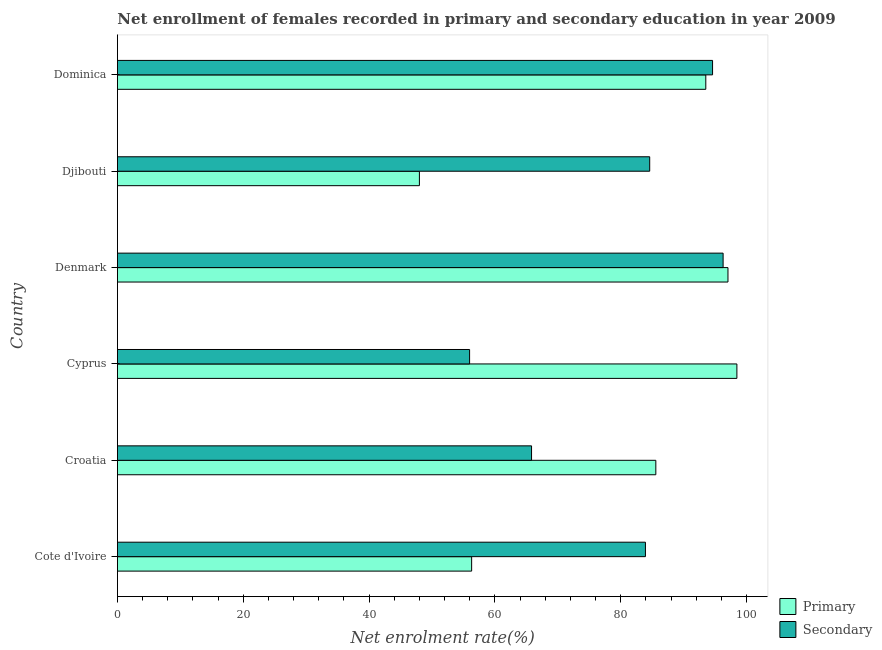How many groups of bars are there?
Your answer should be very brief. 6. Are the number of bars per tick equal to the number of legend labels?
Offer a very short reply. Yes. How many bars are there on the 2nd tick from the top?
Give a very brief answer. 2. How many bars are there on the 2nd tick from the bottom?
Make the answer very short. 2. What is the label of the 6th group of bars from the top?
Offer a terse response. Cote d'Ivoire. In how many cases, is the number of bars for a given country not equal to the number of legend labels?
Your answer should be compact. 0. What is the enrollment rate in primary education in Croatia?
Give a very brief answer. 85.56. Across all countries, what is the maximum enrollment rate in secondary education?
Offer a terse response. 96.26. Across all countries, what is the minimum enrollment rate in primary education?
Give a very brief answer. 47.99. In which country was the enrollment rate in secondary education minimum?
Provide a succinct answer. Cyprus. What is the total enrollment rate in primary education in the graph?
Offer a very short reply. 478.83. What is the difference between the enrollment rate in primary education in Cyprus and that in Dominica?
Your response must be concise. 4.94. What is the difference between the enrollment rate in primary education in Croatia and the enrollment rate in secondary education in Cyprus?
Make the answer very short. 29.59. What is the average enrollment rate in primary education per country?
Your answer should be very brief. 79.8. What is the difference between the enrollment rate in primary education and enrollment rate in secondary education in Croatia?
Provide a short and direct response. 19.75. What is the ratio of the enrollment rate in primary education in Cote d'Ivoire to that in Dominica?
Offer a very short reply. 0.6. Is the enrollment rate in secondary education in Cote d'Ivoire less than that in Denmark?
Ensure brevity in your answer.  Yes. What is the difference between the highest and the second highest enrollment rate in primary education?
Provide a short and direct response. 1.42. What is the difference between the highest and the lowest enrollment rate in secondary education?
Give a very brief answer. 40.29. What does the 2nd bar from the top in Cote d'Ivoire represents?
Give a very brief answer. Primary. What does the 1st bar from the bottom in Djibouti represents?
Ensure brevity in your answer.  Primary. How many countries are there in the graph?
Your response must be concise. 6. Does the graph contain any zero values?
Ensure brevity in your answer.  No. Does the graph contain grids?
Your response must be concise. No. How are the legend labels stacked?
Make the answer very short. Vertical. What is the title of the graph?
Your response must be concise. Net enrollment of females recorded in primary and secondary education in year 2009. Does "Total Population" appear as one of the legend labels in the graph?
Keep it short and to the point. No. What is the label or title of the X-axis?
Give a very brief answer. Net enrolment rate(%). What is the Net enrolment rate(%) in Primary in Cote d'Ivoire?
Provide a succinct answer. 56.29. What is the Net enrolment rate(%) of Secondary in Cote d'Ivoire?
Give a very brief answer. 83.91. What is the Net enrolment rate(%) in Primary in Croatia?
Keep it short and to the point. 85.56. What is the Net enrolment rate(%) of Secondary in Croatia?
Your response must be concise. 65.81. What is the Net enrolment rate(%) in Primary in Cyprus?
Make the answer very short. 98.45. What is the Net enrolment rate(%) of Secondary in Cyprus?
Provide a succinct answer. 55.97. What is the Net enrolment rate(%) of Primary in Denmark?
Give a very brief answer. 97.03. What is the Net enrolment rate(%) of Secondary in Denmark?
Make the answer very short. 96.26. What is the Net enrolment rate(%) of Primary in Djibouti?
Provide a succinct answer. 47.99. What is the Net enrolment rate(%) of Secondary in Djibouti?
Ensure brevity in your answer.  84.59. What is the Net enrolment rate(%) of Primary in Dominica?
Ensure brevity in your answer.  93.5. What is the Net enrolment rate(%) of Secondary in Dominica?
Give a very brief answer. 94.58. Across all countries, what is the maximum Net enrolment rate(%) of Primary?
Keep it short and to the point. 98.45. Across all countries, what is the maximum Net enrolment rate(%) in Secondary?
Your answer should be compact. 96.26. Across all countries, what is the minimum Net enrolment rate(%) in Primary?
Provide a short and direct response. 47.99. Across all countries, what is the minimum Net enrolment rate(%) of Secondary?
Ensure brevity in your answer.  55.97. What is the total Net enrolment rate(%) in Primary in the graph?
Give a very brief answer. 478.83. What is the total Net enrolment rate(%) of Secondary in the graph?
Your response must be concise. 481.12. What is the difference between the Net enrolment rate(%) of Primary in Cote d'Ivoire and that in Croatia?
Ensure brevity in your answer.  -29.27. What is the difference between the Net enrolment rate(%) of Secondary in Cote d'Ivoire and that in Croatia?
Keep it short and to the point. 18.1. What is the difference between the Net enrolment rate(%) in Primary in Cote d'Ivoire and that in Cyprus?
Your answer should be compact. -42.15. What is the difference between the Net enrolment rate(%) in Secondary in Cote d'Ivoire and that in Cyprus?
Your answer should be compact. 27.94. What is the difference between the Net enrolment rate(%) in Primary in Cote d'Ivoire and that in Denmark?
Your response must be concise. -40.73. What is the difference between the Net enrolment rate(%) in Secondary in Cote d'Ivoire and that in Denmark?
Keep it short and to the point. -12.34. What is the difference between the Net enrolment rate(%) in Primary in Cote d'Ivoire and that in Djibouti?
Your answer should be compact. 8.3. What is the difference between the Net enrolment rate(%) of Secondary in Cote d'Ivoire and that in Djibouti?
Provide a succinct answer. -0.68. What is the difference between the Net enrolment rate(%) of Primary in Cote d'Ivoire and that in Dominica?
Provide a succinct answer. -37.21. What is the difference between the Net enrolment rate(%) in Secondary in Cote d'Ivoire and that in Dominica?
Your answer should be compact. -10.67. What is the difference between the Net enrolment rate(%) in Primary in Croatia and that in Cyprus?
Provide a succinct answer. -12.88. What is the difference between the Net enrolment rate(%) of Secondary in Croatia and that in Cyprus?
Your response must be concise. 9.85. What is the difference between the Net enrolment rate(%) of Primary in Croatia and that in Denmark?
Offer a terse response. -11.46. What is the difference between the Net enrolment rate(%) of Secondary in Croatia and that in Denmark?
Keep it short and to the point. -30.44. What is the difference between the Net enrolment rate(%) of Primary in Croatia and that in Djibouti?
Make the answer very short. 37.57. What is the difference between the Net enrolment rate(%) in Secondary in Croatia and that in Djibouti?
Make the answer very short. -18.78. What is the difference between the Net enrolment rate(%) of Primary in Croatia and that in Dominica?
Your response must be concise. -7.94. What is the difference between the Net enrolment rate(%) of Secondary in Croatia and that in Dominica?
Make the answer very short. -28.77. What is the difference between the Net enrolment rate(%) in Primary in Cyprus and that in Denmark?
Provide a short and direct response. 1.42. What is the difference between the Net enrolment rate(%) of Secondary in Cyprus and that in Denmark?
Make the answer very short. -40.29. What is the difference between the Net enrolment rate(%) of Primary in Cyprus and that in Djibouti?
Your answer should be very brief. 50.45. What is the difference between the Net enrolment rate(%) in Secondary in Cyprus and that in Djibouti?
Your answer should be compact. -28.62. What is the difference between the Net enrolment rate(%) of Primary in Cyprus and that in Dominica?
Make the answer very short. 4.94. What is the difference between the Net enrolment rate(%) in Secondary in Cyprus and that in Dominica?
Give a very brief answer. -38.61. What is the difference between the Net enrolment rate(%) of Primary in Denmark and that in Djibouti?
Give a very brief answer. 49.03. What is the difference between the Net enrolment rate(%) of Secondary in Denmark and that in Djibouti?
Your answer should be compact. 11.66. What is the difference between the Net enrolment rate(%) in Primary in Denmark and that in Dominica?
Make the answer very short. 3.52. What is the difference between the Net enrolment rate(%) of Secondary in Denmark and that in Dominica?
Offer a very short reply. 1.68. What is the difference between the Net enrolment rate(%) in Primary in Djibouti and that in Dominica?
Your answer should be very brief. -45.51. What is the difference between the Net enrolment rate(%) of Secondary in Djibouti and that in Dominica?
Your response must be concise. -9.99. What is the difference between the Net enrolment rate(%) in Primary in Cote d'Ivoire and the Net enrolment rate(%) in Secondary in Croatia?
Provide a short and direct response. -9.52. What is the difference between the Net enrolment rate(%) of Primary in Cote d'Ivoire and the Net enrolment rate(%) of Secondary in Cyprus?
Make the answer very short. 0.32. What is the difference between the Net enrolment rate(%) of Primary in Cote d'Ivoire and the Net enrolment rate(%) of Secondary in Denmark?
Your response must be concise. -39.96. What is the difference between the Net enrolment rate(%) of Primary in Cote d'Ivoire and the Net enrolment rate(%) of Secondary in Djibouti?
Offer a terse response. -28.3. What is the difference between the Net enrolment rate(%) of Primary in Cote d'Ivoire and the Net enrolment rate(%) of Secondary in Dominica?
Ensure brevity in your answer.  -38.29. What is the difference between the Net enrolment rate(%) of Primary in Croatia and the Net enrolment rate(%) of Secondary in Cyprus?
Provide a short and direct response. 29.59. What is the difference between the Net enrolment rate(%) of Primary in Croatia and the Net enrolment rate(%) of Secondary in Denmark?
Offer a very short reply. -10.69. What is the difference between the Net enrolment rate(%) in Primary in Croatia and the Net enrolment rate(%) in Secondary in Djibouti?
Make the answer very short. 0.97. What is the difference between the Net enrolment rate(%) in Primary in Croatia and the Net enrolment rate(%) in Secondary in Dominica?
Ensure brevity in your answer.  -9.02. What is the difference between the Net enrolment rate(%) in Primary in Cyprus and the Net enrolment rate(%) in Secondary in Denmark?
Your response must be concise. 2.19. What is the difference between the Net enrolment rate(%) in Primary in Cyprus and the Net enrolment rate(%) in Secondary in Djibouti?
Your answer should be very brief. 13.85. What is the difference between the Net enrolment rate(%) in Primary in Cyprus and the Net enrolment rate(%) in Secondary in Dominica?
Ensure brevity in your answer.  3.87. What is the difference between the Net enrolment rate(%) of Primary in Denmark and the Net enrolment rate(%) of Secondary in Djibouti?
Make the answer very short. 12.44. What is the difference between the Net enrolment rate(%) in Primary in Denmark and the Net enrolment rate(%) in Secondary in Dominica?
Your answer should be very brief. 2.45. What is the difference between the Net enrolment rate(%) of Primary in Djibouti and the Net enrolment rate(%) of Secondary in Dominica?
Provide a succinct answer. -46.59. What is the average Net enrolment rate(%) of Primary per country?
Make the answer very short. 79.8. What is the average Net enrolment rate(%) of Secondary per country?
Your answer should be very brief. 80.19. What is the difference between the Net enrolment rate(%) in Primary and Net enrolment rate(%) in Secondary in Cote d'Ivoire?
Give a very brief answer. -27.62. What is the difference between the Net enrolment rate(%) of Primary and Net enrolment rate(%) of Secondary in Croatia?
Offer a terse response. 19.75. What is the difference between the Net enrolment rate(%) in Primary and Net enrolment rate(%) in Secondary in Cyprus?
Ensure brevity in your answer.  42.48. What is the difference between the Net enrolment rate(%) of Primary and Net enrolment rate(%) of Secondary in Denmark?
Your answer should be compact. 0.77. What is the difference between the Net enrolment rate(%) in Primary and Net enrolment rate(%) in Secondary in Djibouti?
Ensure brevity in your answer.  -36.6. What is the difference between the Net enrolment rate(%) of Primary and Net enrolment rate(%) of Secondary in Dominica?
Make the answer very short. -1.07. What is the ratio of the Net enrolment rate(%) in Primary in Cote d'Ivoire to that in Croatia?
Give a very brief answer. 0.66. What is the ratio of the Net enrolment rate(%) in Secondary in Cote d'Ivoire to that in Croatia?
Offer a very short reply. 1.27. What is the ratio of the Net enrolment rate(%) in Primary in Cote d'Ivoire to that in Cyprus?
Offer a terse response. 0.57. What is the ratio of the Net enrolment rate(%) of Secondary in Cote d'Ivoire to that in Cyprus?
Make the answer very short. 1.5. What is the ratio of the Net enrolment rate(%) in Primary in Cote d'Ivoire to that in Denmark?
Make the answer very short. 0.58. What is the ratio of the Net enrolment rate(%) of Secondary in Cote d'Ivoire to that in Denmark?
Your answer should be compact. 0.87. What is the ratio of the Net enrolment rate(%) of Primary in Cote d'Ivoire to that in Djibouti?
Make the answer very short. 1.17. What is the ratio of the Net enrolment rate(%) in Secondary in Cote d'Ivoire to that in Djibouti?
Make the answer very short. 0.99. What is the ratio of the Net enrolment rate(%) of Primary in Cote d'Ivoire to that in Dominica?
Make the answer very short. 0.6. What is the ratio of the Net enrolment rate(%) in Secondary in Cote d'Ivoire to that in Dominica?
Provide a succinct answer. 0.89. What is the ratio of the Net enrolment rate(%) in Primary in Croatia to that in Cyprus?
Your answer should be very brief. 0.87. What is the ratio of the Net enrolment rate(%) of Secondary in Croatia to that in Cyprus?
Your answer should be compact. 1.18. What is the ratio of the Net enrolment rate(%) in Primary in Croatia to that in Denmark?
Offer a terse response. 0.88. What is the ratio of the Net enrolment rate(%) of Secondary in Croatia to that in Denmark?
Your answer should be compact. 0.68. What is the ratio of the Net enrolment rate(%) of Primary in Croatia to that in Djibouti?
Give a very brief answer. 1.78. What is the ratio of the Net enrolment rate(%) of Secondary in Croatia to that in Djibouti?
Provide a short and direct response. 0.78. What is the ratio of the Net enrolment rate(%) in Primary in Croatia to that in Dominica?
Your answer should be very brief. 0.92. What is the ratio of the Net enrolment rate(%) of Secondary in Croatia to that in Dominica?
Your answer should be very brief. 0.7. What is the ratio of the Net enrolment rate(%) in Primary in Cyprus to that in Denmark?
Offer a terse response. 1.01. What is the ratio of the Net enrolment rate(%) of Secondary in Cyprus to that in Denmark?
Make the answer very short. 0.58. What is the ratio of the Net enrolment rate(%) in Primary in Cyprus to that in Djibouti?
Your answer should be very brief. 2.05. What is the ratio of the Net enrolment rate(%) of Secondary in Cyprus to that in Djibouti?
Give a very brief answer. 0.66. What is the ratio of the Net enrolment rate(%) in Primary in Cyprus to that in Dominica?
Give a very brief answer. 1.05. What is the ratio of the Net enrolment rate(%) of Secondary in Cyprus to that in Dominica?
Your answer should be very brief. 0.59. What is the ratio of the Net enrolment rate(%) of Primary in Denmark to that in Djibouti?
Your response must be concise. 2.02. What is the ratio of the Net enrolment rate(%) in Secondary in Denmark to that in Djibouti?
Offer a very short reply. 1.14. What is the ratio of the Net enrolment rate(%) of Primary in Denmark to that in Dominica?
Your answer should be compact. 1.04. What is the ratio of the Net enrolment rate(%) of Secondary in Denmark to that in Dominica?
Make the answer very short. 1.02. What is the ratio of the Net enrolment rate(%) of Primary in Djibouti to that in Dominica?
Offer a terse response. 0.51. What is the ratio of the Net enrolment rate(%) in Secondary in Djibouti to that in Dominica?
Your answer should be compact. 0.89. What is the difference between the highest and the second highest Net enrolment rate(%) in Primary?
Your answer should be compact. 1.42. What is the difference between the highest and the second highest Net enrolment rate(%) in Secondary?
Your answer should be very brief. 1.68. What is the difference between the highest and the lowest Net enrolment rate(%) in Primary?
Ensure brevity in your answer.  50.45. What is the difference between the highest and the lowest Net enrolment rate(%) of Secondary?
Provide a short and direct response. 40.29. 